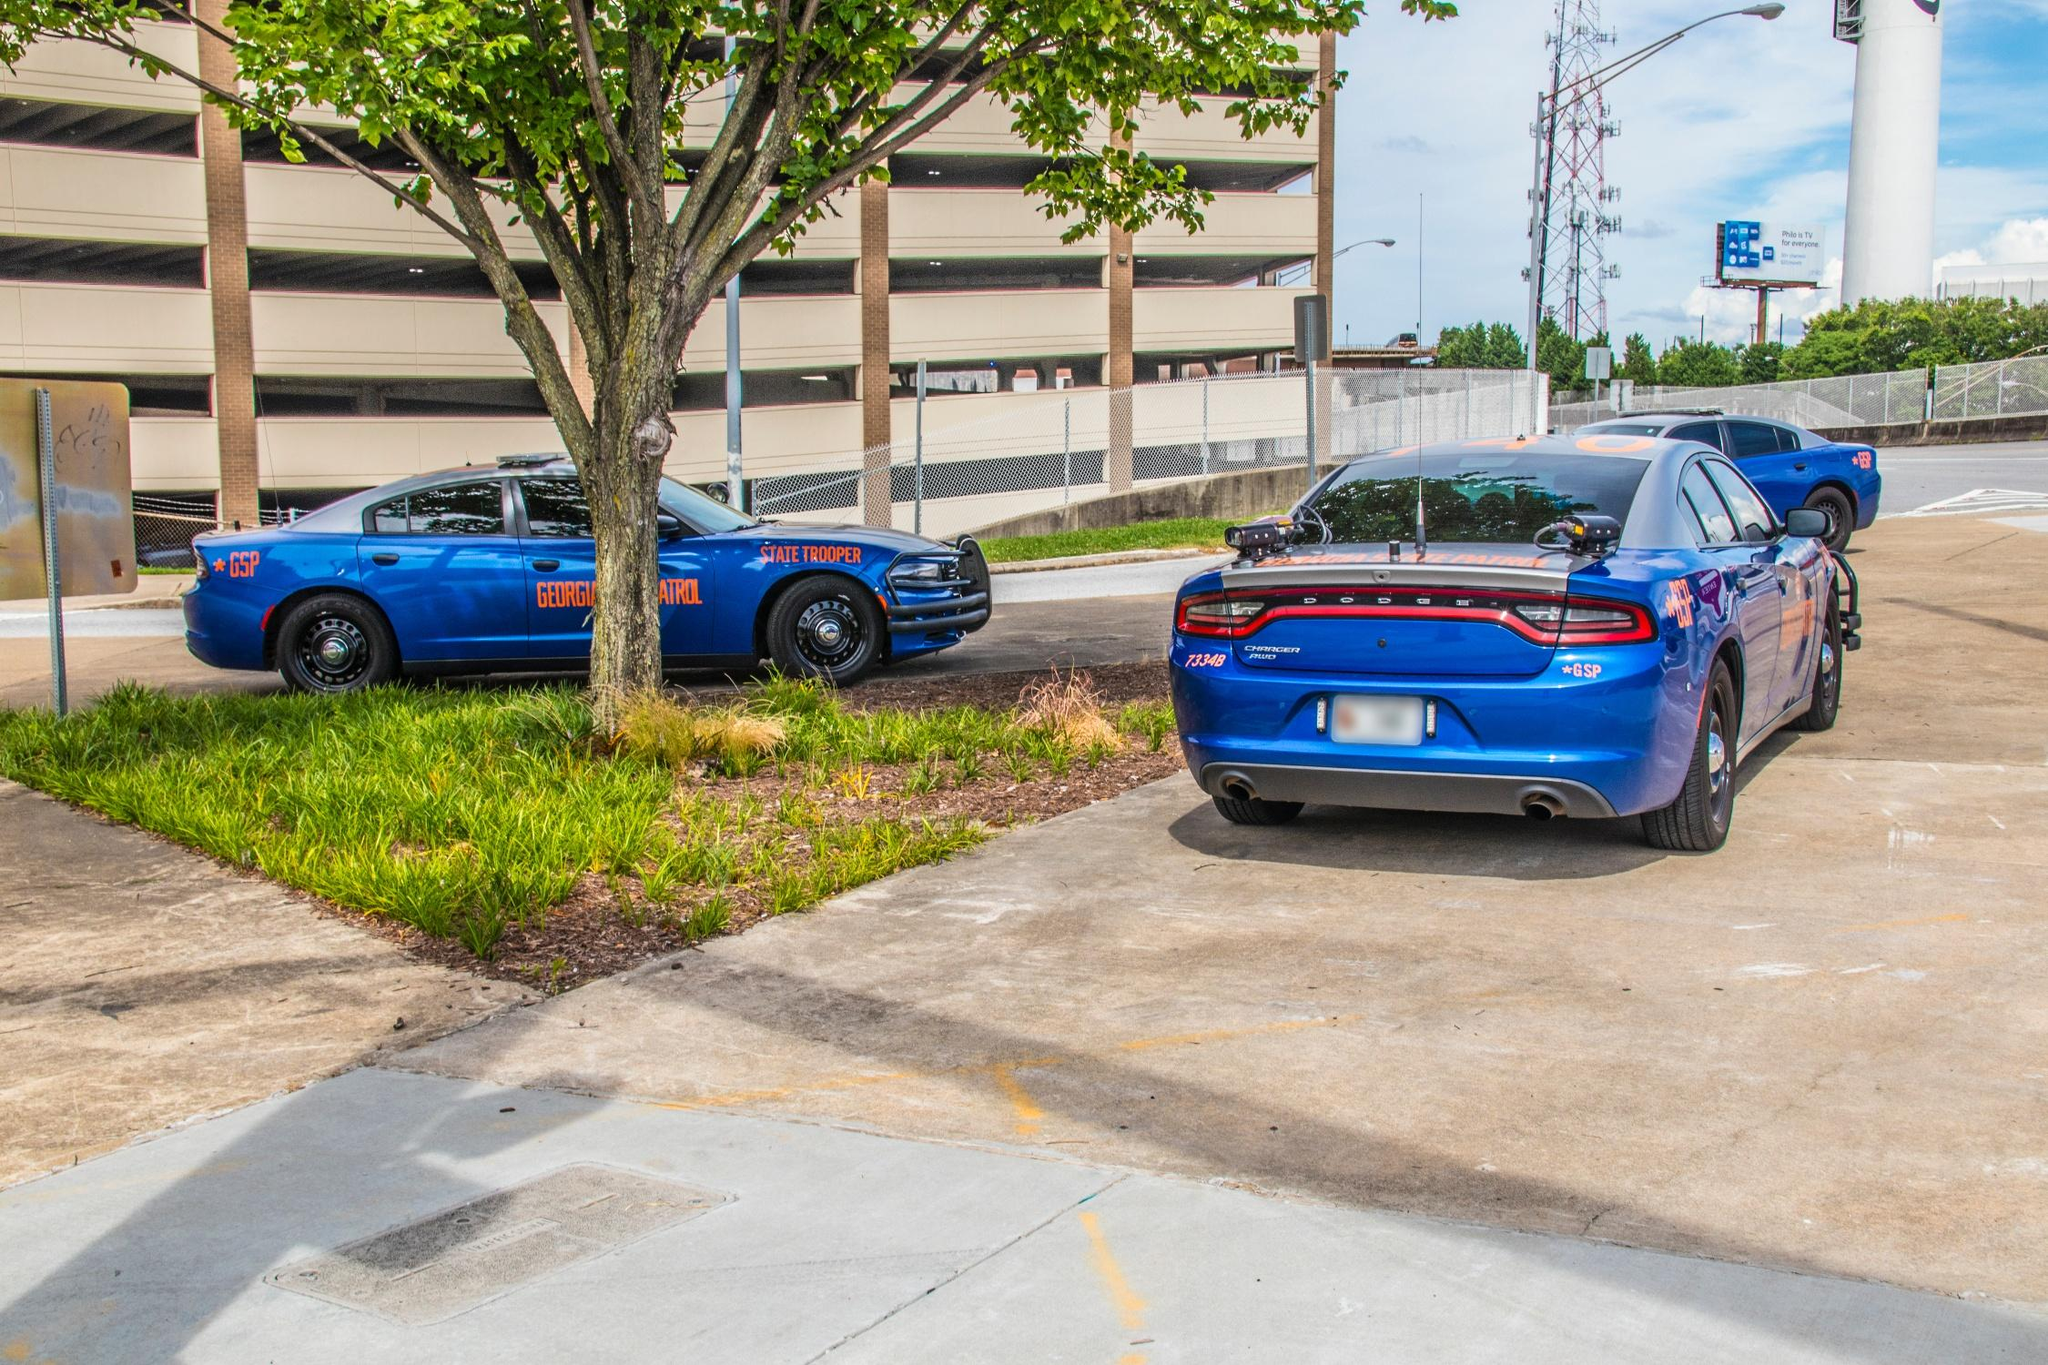What can be inferred about the location from the architectural and natural elements visible in the background and surrounding area? From the architectural and natural elements visible, this location is likely on the outskirts of a larger city or in a suburban area designed with both aesthetic and functionality in mind. The presence of a layered parking facility suggests this area could be adjacent to a major public or governmental building, possibly a courthouse or state facility, where law enforcement presence would be prioritized. The meticulously maintained green space and tree indicate an attempt to blend utility with environmental considerations, making the area welcoming while still serving its primary functional needs. 